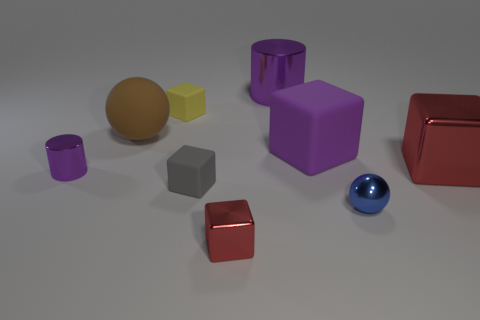Subtract all tiny red cubes. How many cubes are left? 4 Subtract all purple cubes. How many cubes are left? 4 Subtract all brown blocks. Subtract all purple cylinders. How many blocks are left? 5 Subtract all spheres. How many objects are left? 7 Subtract all small cylinders. Subtract all large rubber balls. How many objects are left? 7 Add 2 brown balls. How many brown balls are left? 3 Add 3 small spheres. How many small spheres exist? 4 Subtract 1 purple blocks. How many objects are left? 8 